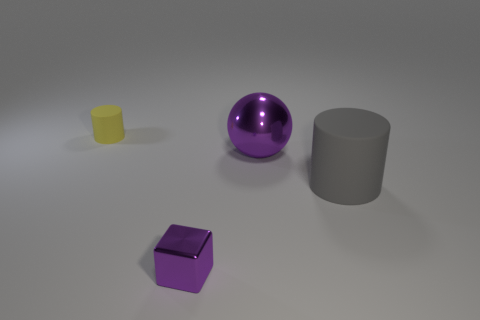What shapes are visible in the image? In the image, there are four distinct shapes: a cylinder, a sphere, a cube, and a cuboid. Each object has a clearly defined geometric form, presenting various basic three-dimensional shapes. 